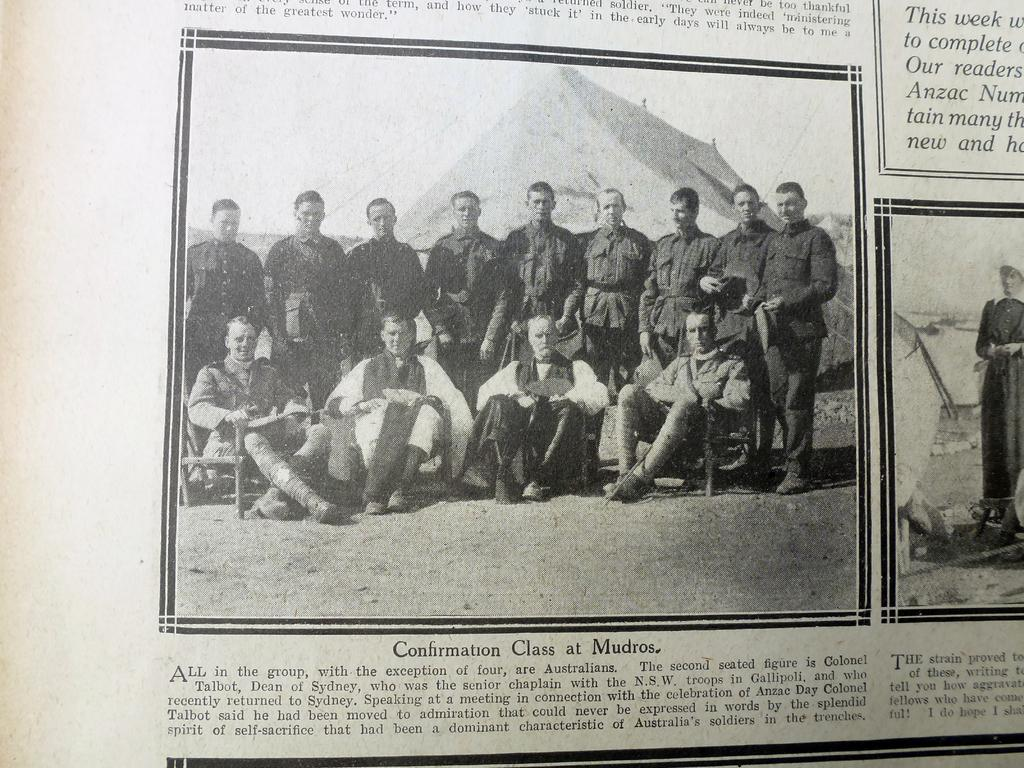What is the main subject of the image? There is an article in the image. What can be found within the article? There are two pictures in the article. What do the pictures depict? The pictures contain people. How many toes can be seen on the people in the pictures? There is no information about the number of toes visible in the image, as the focus is on the people and not their toes. 